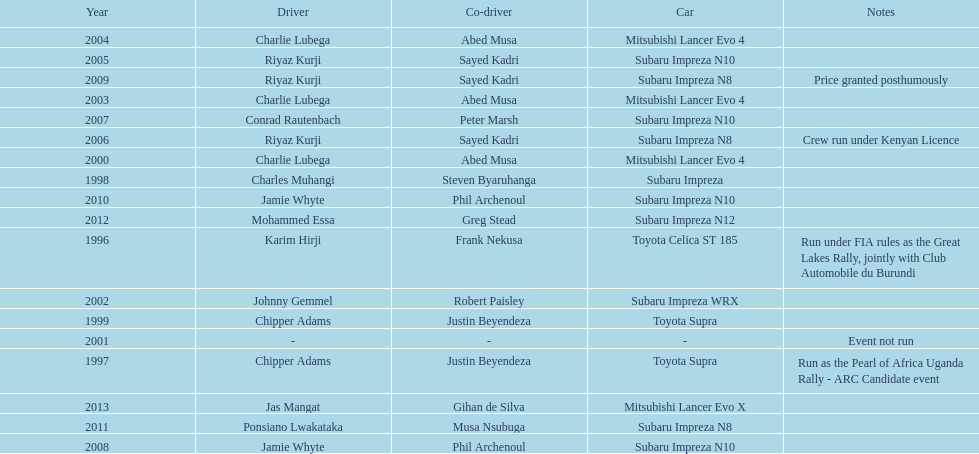How many times was a mitsubishi lancer the winning car before the year 2004? 2. 